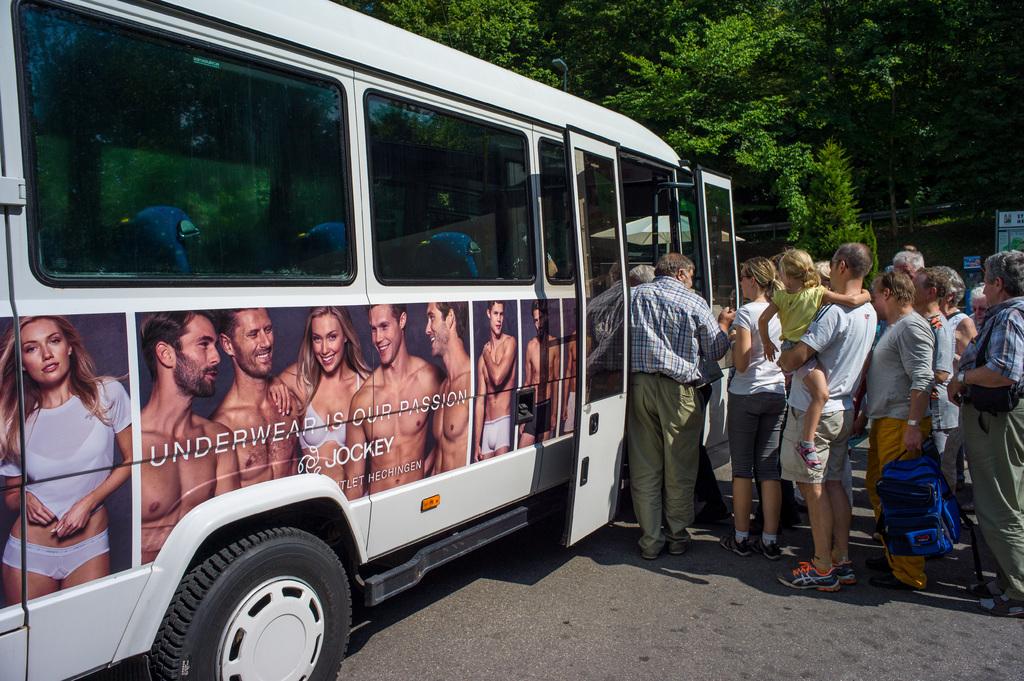What brand of under garment are the people wearing on the bus?
Offer a very short reply. Jockey. What color is the text on the bus?
Your answer should be compact. White. 